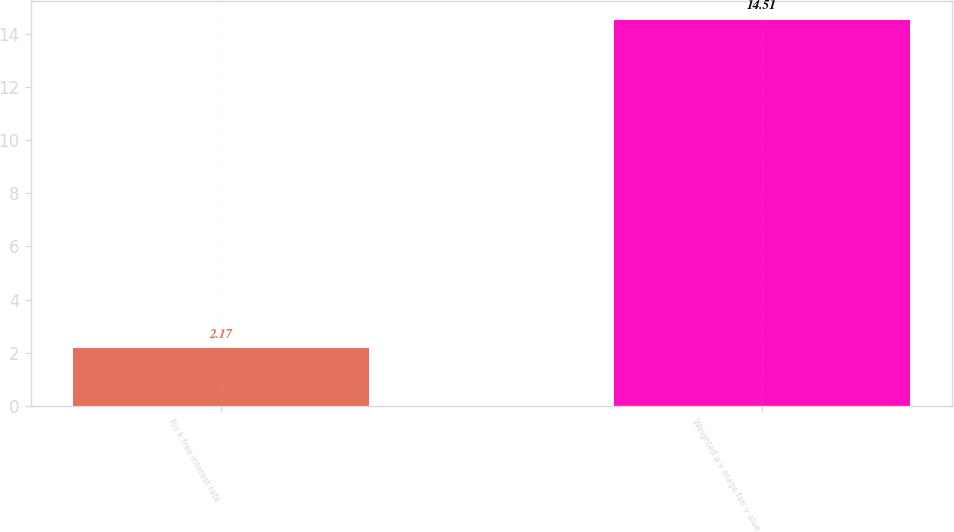<chart> <loc_0><loc_0><loc_500><loc_500><bar_chart><fcel>Ris k free interest rate<fcel>Weighted a v erage fair v alue<nl><fcel>2.17<fcel>14.51<nl></chart> 